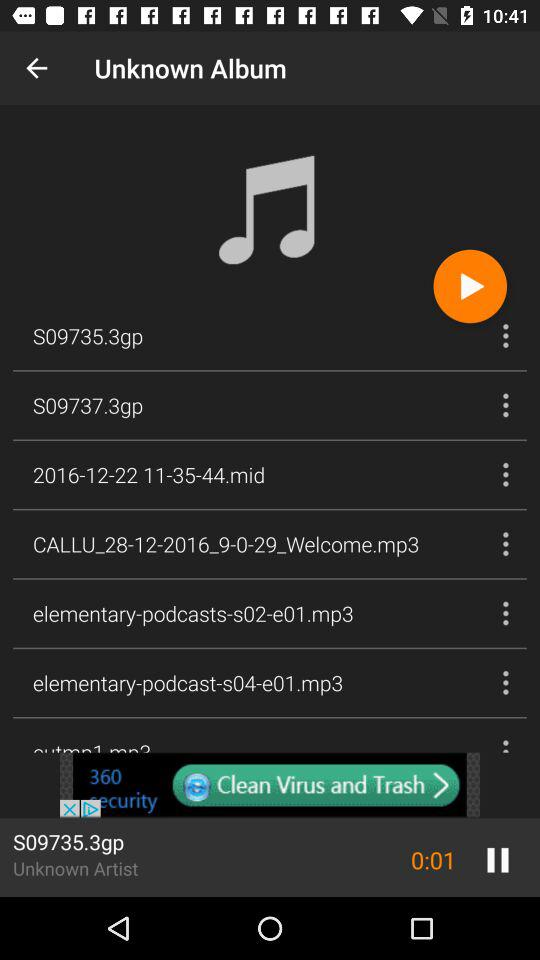How many seconds have elapsed in the current song?
Answer the question using a single word or phrase. 1 